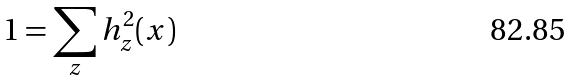<formula> <loc_0><loc_0><loc_500><loc_500>1 = \sum _ { z } h _ { z } ^ { 2 } ( x )</formula> 